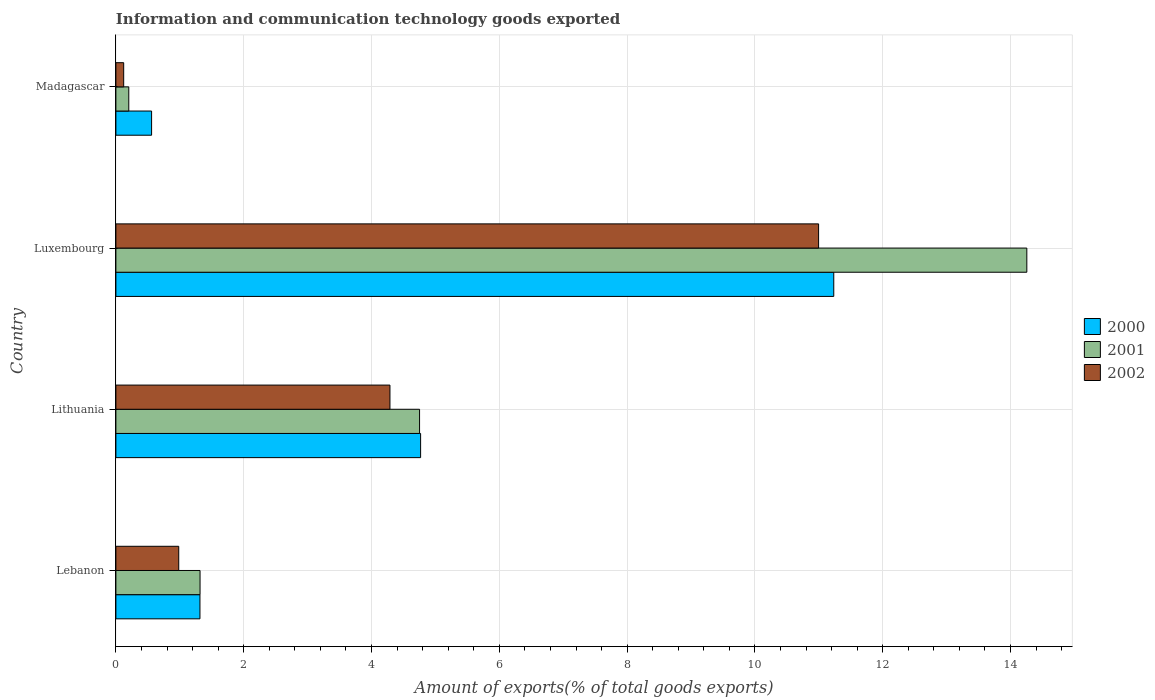How many groups of bars are there?
Provide a succinct answer. 4. How many bars are there on the 2nd tick from the top?
Your response must be concise. 3. What is the label of the 3rd group of bars from the top?
Offer a very short reply. Lithuania. In how many cases, is the number of bars for a given country not equal to the number of legend labels?
Ensure brevity in your answer.  0. What is the amount of goods exported in 2000 in Lebanon?
Your response must be concise. 1.32. Across all countries, what is the maximum amount of goods exported in 2000?
Offer a very short reply. 11.23. Across all countries, what is the minimum amount of goods exported in 2002?
Make the answer very short. 0.12. In which country was the amount of goods exported in 2001 maximum?
Give a very brief answer. Luxembourg. In which country was the amount of goods exported in 2000 minimum?
Provide a succinct answer. Madagascar. What is the total amount of goods exported in 2000 in the graph?
Your answer should be compact. 17.88. What is the difference between the amount of goods exported in 2001 in Lebanon and that in Lithuania?
Ensure brevity in your answer.  -3.44. What is the difference between the amount of goods exported in 2001 in Lithuania and the amount of goods exported in 2002 in Madagascar?
Provide a succinct answer. 4.63. What is the average amount of goods exported in 2002 per country?
Keep it short and to the point. 4.1. What is the difference between the amount of goods exported in 2002 and amount of goods exported in 2001 in Luxembourg?
Offer a terse response. -3.26. What is the ratio of the amount of goods exported in 2002 in Lithuania to that in Luxembourg?
Ensure brevity in your answer.  0.39. What is the difference between the highest and the second highest amount of goods exported in 2002?
Provide a succinct answer. 6.71. What is the difference between the highest and the lowest amount of goods exported in 2001?
Your answer should be compact. 14.05. In how many countries, is the amount of goods exported in 2000 greater than the average amount of goods exported in 2000 taken over all countries?
Your answer should be compact. 2. What does the 1st bar from the top in Madagascar represents?
Your answer should be very brief. 2002. Is it the case that in every country, the sum of the amount of goods exported in 2000 and amount of goods exported in 2001 is greater than the amount of goods exported in 2002?
Offer a very short reply. Yes. How many bars are there?
Ensure brevity in your answer.  12. How many countries are there in the graph?
Offer a very short reply. 4. What is the difference between two consecutive major ticks on the X-axis?
Ensure brevity in your answer.  2. Does the graph contain grids?
Make the answer very short. Yes. What is the title of the graph?
Keep it short and to the point. Information and communication technology goods exported. Does "1960" appear as one of the legend labels in the graph?
Offer a terse response. No. What is the label or title of the X-axis?
Ensure brevity in your answer.  Amount of exports(% of total goods exports). What is the label or title of the Y-axis?
Your answer should be compact. Country. What is the Amount of exports(% of total goods exports) in 2000 in Lebanon?
Keep it short and to the point. 1.32. What is the Amount of exports(% of total goods exports) of 2001 in Lebanon?
Offer a very short reply. 1.32. What is the Amount of exports(% of total goods exports) of 2002 in Lebanon?
Provide a short and direct response. 0.98. What is the Amount of exports(% of total goods exports) of 2000 in Lithuania?
Your answer should be compact. 4.77. What is the Amount of exports(% of total goods exports) of 2001 in Lithuania?
Your answer should be very brief. 4.75. What is the Amount of exports(% of total goods exports) in 2002 in Lithuania?
Ensure brevity in your answer.  4.29. What is the Amount of exports(% of total goods exports) of 2000 in Luxembourg?
Keep it short and to the point. 11.23. What is the Amount of exports(% of total goods exports) of 2001 in Luxembourg?
Provide a short and direct response. 14.25. What is the Amount of exports(% of total goods exports) in 2002 in Luxembourg?
Offer a terse response. 11. What is the Amount of exports(% of total goods exports) of 2000 in Madagascar?
Your response must be concise. 0.56. What is the Amount of exports(% of total goods exports) in 2001 in Madagascar?
Your response must be concise. 0.2. What is the Amount of exports(% of total goods exports) of 2002 in Madagascar?
Your answer should be compact. 0.12. Across all countries, what is the maximum Amount of exports(% of total goods exports) of 2000?
Offer a terse response. 11.23. Across all countries, what is the maximum Amount of exports(% of total goods exports) of 2001?
Offer a very short reply. 14.25. Across all countries, what is the maximum Amount of exports(% of total goods exports) of 2002?
Your response must be concise. 11. Across all countries, what is the minimum Amount of exports(% of total goods exports) of 2000?
Give a very brief answer. 0.56. Across all countries, what is the minimum Amount of exports(% of total goods exports) of 2001?
Offer a very short reply. 0.2. Across all countries, what is the minimum Amount of exports(% of total goods exports) of 2002?
Give a very brief answer. 0.12. What is the total Amount of exports(% of total goods exports) of 2000 in the graph?
Make the answer very short. 17.88. What is the total Amount of exports(% of total goods exports) of 2001 in the graph?
Your answer should be very brief. 20.53. What is the total Amount of exports(% of total goods exports) in 2002 in the graph?
Offer a very short reply. 16.39. What is the difference between the Amount of exports(% of total goods exports) in 2000 in Lebanon and that in Lithuania?
Make the answer very short. -3.45. What is the difference between the Amount of exports(% of total goods exports) of 2001 in Lebanon and that in Lithuania?
Make the answer very short. -3.44. What is the difference between the Amount of exports(% of total goods exports) in 2002 in Lebanon and that in Lithuania?
Ensure brevity in your answer.  -3.31. What is the difference between the Amount of exports(% of total goods exports) in 2000 in Lebanon and that in Luxembourg?
Provide a short and direct response. -9.92. What is the difference between the Amount of exports(% of total goods exports) of 2001 in Lebanon and that in Luxembourg?
Provide a succinct answer. -12.94. What is the difference between the Amount of exports(% of total goods exports) of 2002 in Lebanon and that in Luxembourg?
Your response must be concise. -10.01. What is the difference between the Amount of exports(% of total goods exports) in 2000 in Lebanon and that in Madagascar?
Provide a short and direct response. 0.76. What is the difference between the Amount of exports(% of total goods exports) in 2001 in Lebanon and that in Madagascar?
Your response must be concise. 1.12. What is the difference between the Amount of exports(% of total goods exports) in 2002 in Lebanon and that in Madagascar?
Offer a very short reply. 0.86. What is the difference between the Amount of exports(% of total goods exports) of 2000 in Lithuania and that in Luxembourg?
Make the answer very short. -6.47. What is the difference between the Amount of exports(% of total goods exports) in 2001 in Lithuania and that in Luxembourg?
Keep it short and to the point. -9.5. What is the difference between the Amount of exports(% of total goods exports) in 2002 in Lithuania and that in Luxembourg?
Give a very brief answer. -6.71. What is the difference between the Amount of exports(% of total goods exports) of 2000 in Lithuania and that in Madagascar?
Offer a very short reply. 4.21. What is the difference between the Amount of exports(% of total goods exports) in 2001 in Lithuania and that in Madagascar?
Ensure brevity in your answer.  4.55. What is the difference between the Amount of exports(% of total goods exports) in 2002 in Lithuania and that in Madagascar?
Keep it short and to the point. 4.17. What is the difference between the Amount of exports(% of total goods exports) in 2000 in Luxembourg and that in Madagascar?
Make the answer very short. 10.68. What is the difference between the Amount of exports(% of total goods exports) of 2001 in Luxembourg and that in Madagascar?
Provide a succinct answer. 14.05. What is the difference between the Amount of exports(% of total goods exports) of 2002 in Luxembourg and that in Madagascar?
Offer a terse response. 10.87. What is the difference between the Amount of exports(% of total goods exports) of 2000 in Lebanon and the Amount of exports(% of total goods exports) of 2001 in Lithuania?
Your response must be concise. -3.44. What is the difference between the Amount of exports(% of total goods exports) in 2000 in Lebanon and the Amount of exports(% of total goods exports) in 2002 in Lithuania?
Keep it short and to the point. -2.97. What is the difference between the Amount of exports(% of total goods exports) in 2001 in Lebanon and the Amount of exports(% of total goods exports) in 2002 in Lithuania?
Your response must be concise. -2.97. What is the difference between the Amount of exports(% of total goods exports) of 2000 in Lebanon and the Amount of exports(% of total goods exports) of 2001 in Luxembourg?
Keep it short and to the point. -12.94. What is the difference between the Amount of exports(% of total goods exports) in 2000 in Lebanon and the Amount of exports(% of total goods exports) in 2002 in Luxembourg?
Provide a succinct answer. -9.68. What is the difference between the Amount of exports(% of total goods exports) of 2001 in Lebanon and the Amount of exports(% of total goods exports) of 2002 in Luxembourg?
Offer a very short reply. -9.68. What is the difference between the Amount of exports(% of total goods exports) in 2000 in Lebanon and the Amount of exports(% of total goods exports) in 2001 in Madagascar?
Give a very brief answer. 1.11. What is the difference between the Amount of exports(% of total goods exports) in 2000 in Lebanon and the Amount of exports(% of total goods exports) in 2002 in Madagascar?
Make the answer very short. 1.19. What is the difference between the Amount of exports(% of total goods exports) of 2001 in Lebanon and the Amount of exports(% of total goods exports) of 2002 in Madagascar?
Offer a terse response. 1.19. What is the difference between the Amount of exports(% of total goods exports) of 2000 in Lithuania and the Amount of exports(% of total goods exports) of 2001 in Luxembourg?
Provide a succinct answer. -9.49. What is the difference between the Amount of exports(% of total goods exports) in 2000 in Lithuania and the Amount of exports(% of total goods exports) in 2002 in Luxembourg?
Make the answer very short. -6.23. What is the difference between the Amount of exports(% of total goods exports) in 2001 in Lithuania and the Amount of exports(% of total goods exports) in 2002 in Luxembourg?
Offer a very short reply. -6.24. What is the difference between the Amount of exports(% of total goods exports) in 2000 in Lithuania and the Amount of exports(% of total goods exports) in 2001 in Madagascar?
Make the answer very short. 4.57. What is the difference between the Amount of exports(% of total goods exports) of 2000 in Lithuania and the Amount of exports(% of total goods exports) of 2002 in Madagascar?
Your response must be concise. 4.65. What is the difference between the Amount of exports(% of total goods exports) in 2001 in Lithuania and the Amount of exports(% of total goods exports) in 2002 in Madagascar?
Keep it short and to the point. 4.63. What is the difference between the Amount of exports(% of total goods exports) of 2000 in Luxembourg and the Amount of exports(% of total goods exports) of 2001 in Madagascar?
Your answer should be compact. 11.03. What is the difference between the Amount of exports(% of total goods exports) in 2000 in Luxembourg and the Amount of exports(% of total goods exports) in 2002 in Madagascar?
Provide a succinct answer. 11.11. What is the difference between the Amount of exports(% of total goods exports) in 2001 in Luxembourg and the Amount of exports(% of total goods exports) in 2002 in Madagascar?
Offer a terse response. 14.13. What is the average Amount of exports(% of total goods exports) of 2000 per country?
Offer a terse response. 4.47. What is the average Amount of exports(% of total goods exports) in 2001 per country?
Provide a succinct answer. 5.13. What is the average Amount of exports(% of total goods exports) in 2002 per country?
Your response must be concise. 4.1. What is the difference between the Amount of exports(% of total goods exports) in 2000 and Amount of exports(% of total goods exports) in 2001 in Lebanon?
Provide a short and direct response. -0. What is the difference between the Amount of exports(% of total goods exports) in 2000 and Amount of exports(% of total goods exports) in 2002 in Lebanon?
Your answer should be very brief. 0.33. What is the difference between the Amount of exports(% of total goods exports) of 2001 and Amount of exports(% of total goods exports) of 2002 in Lebanon?
Make the answer very short. 0.33. What is the difference between the Amount of exports(% of total goods exports) in 2000 and Amount of exports(% of total goods exports) in 2001 in Lithuania?
Keep it short and to the point. 0.02. What is the difference between the Amount of exports(% of total goods exports) of 2000 and Amount of exports(% of total goods exports) of 2002 in Lithuania?
Make the answer very short. 0.48. What is the difference between the Amount of exports(% of total goods exports) in 2001 and Amount of exports(% of total goods exports) in 2002 in Lithuania?
Your answer should be compact. 0.46. What is the difference between the Amount of exports(% of total goods exports) in 2000 and Amount of exports(% of total goods exports) in 2001 in Luxembourg?
Provide a succinct answer. -3.02. What is the difference between the Amount of exports(% of total goods exports) of 2000 and Amount of exports(% of total goods exports) of 2002 in Luxembourg?
Your answer should be very brief. 0.24. What is the difference between the Amount of exports(% of total goods exports) in 2001 and Amount of exports(% of total goods exports) in 2002 in Luxembourg?
Provide a short and direct response. 3.26. What is the difference between the Amount of exports(% of total goods exports) of 2000 and Amount of exports(% of total goods exports) of 2001 in Madagascar?
Ensure brevity in your answer.  0.36. What is the difference between the Amount of exports(% of total goods exports) of 2000 and Amount of exports(% of total goods exports) of 2002 in Madagascar?
Keep it short and to the point. 0.44. What is the difference between the Amount of exports(% of total goods exports) in 2001 and Amount of exports(% of total goods exports) in 2002 in Madagascar?
Give a very brief answer. 0.08. What is the ratio of the Amount of exports(% of total goods exports) of 2000 in Lebanon to that in Lithuania?
Offer a very short reply. 0.28. What is the ratio of the Amount of exports(% of total goods exports) of 2001 in Lebanon to that in Lithuania?
Keep it short and to the point. 0.28. What is the ratio of the Amount of exports(% of total goods exports) in 2002 in Lebanon to that in Lithuania?
Your response must be concise. 0.23. What is the ratio of the Amount of exports(% of total goods exports) in 2000 in Lebanon to that in Luxembourg?
Provide a succinct answer. 0.12. What is the ratio of the Amount of exports(% of total goods exports) in 2001 in Lebanon to that in Luxembourg?
Make the answer very short. 0.09. What is the ratio of the Amount of exports(% of total goods exports) in 2002 in Lebanon to that in Luxembourg?
Provide a short and direct response. 0.09. What is the ratio of the Amount of exports(% of total goods exports) in 2000 in Lebanon to that in Madagascar?
Offer a terse response. 2.35. What is the ratio of the Amount of exports(% of total goods exports) in 2001 in Lebanon to that in Madagascar?
Give a very brief answer. 6.53. What is the ratio of the Amount of exports(% of total goods exports) of 2002 in Lebanon to that in Madagascar?
Make the answer very short. 8.06. What is the ratio of the Amount of exports(% of total goods exports) of 2000 in Lithuania to that in Luxembourg?
Your response must be concise. 0.42. What is the ratio of the Amount of exports(% of total goods exports) in 2001 in Lithuania to that in Luxembourg?
Offer a very short reply. 0.33. What is the ratio of the Amount of exports(% of total goods exports) in 2002 in Lithuania to that in Luxembourg?
Your answer should be compact. 0.39. What is the ratio of the Amount of exports(% of total goods exports) of 2000 in Lithuania to that in Madagascar?
Your response must be concise. 8.53. What is the ratio of the Amount of exports(% of total goods exports) in 2001 in Lithuania to that in Madagascar?
Offer a terse response. 23.56. What is the ratio of the Amount of exports(% of total goods exports) in 2002 in Lithuania to that in Madagascar?
Ensure brevity in your answer.  35.14. What is the ratio of the Amount of exports(% of total goods exports) in 2000 in Luxembourg to that in Madagascar?
Your response must be concise. 20.11. What is the ratio of the Amount of exports(% of total goods exports) of 2001 in Luxembourg to that in Madagascar?
Ensure brevity in your answer.  70.68. What is the ratio of the Amount of exports(% of total goods exports) of 2002 in Luxembourg to that in Madagascar?
Keep it short and to the point. 90.09. What is the difference between the highest and the second highest Amount of exports(% of total goods exports) of 2000?
Provide a short and direct response. 6.47. What is the difference between the highest and the second highest Amount of exports(% of total goods exports) of 2001?
Your answer should be very brief. 9.5. What is the difference between the highest and the second highest Amount of exports(% of total goods exports) in 2002?
Offer a very short reply. 6.71. What is the difference between the highest and the lowest Amount of exports(% of total goods exports) in 2000?
Provide a short and direct response. 10.68. What is the difference between the highest and the lowest Amount of exports(% of total goods exports) of 2001?
Provide a short and direct response. 14.05. What is the difference between the highest and the lowest Amount of exports(% of total goods exports) of 2002?
Provide a succinct answer. 10.87. 